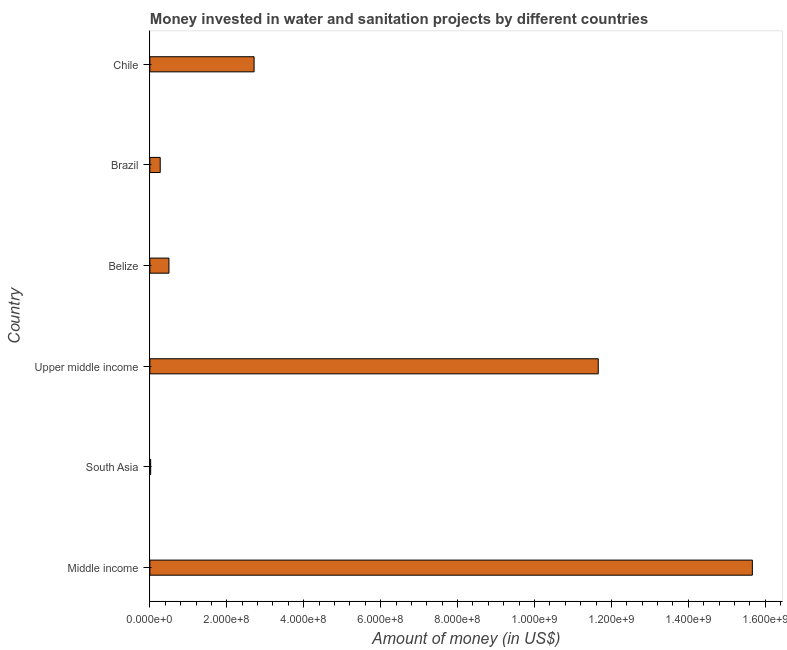Does the graph contain any zero values?
Keep it short and to the point. No. Does the graph contain grids?
Ensure brevity in your answer.  No. What is the title of the graph?
Your answer should be compact. Money invested in water and sanitation projects by different countries. What is the label or title of the X-axis?
Your answer should be compact. Amount of money (in US$). What is the label or title of the Y-axis?
Keep it short and to the point. Country. What is the investment in Brazil?
Provide a short and direct response. 2.69e+07. Across all countries, what is the maximum investment?
Offer a terse response. 1.57e+09. Across all countries, what is the minimum investment?
Give a very brief answer. 2.10e+06. In which country was the investment maximum?
Provide a succinct answer. Middle income. In which country was the investment minimum?
Provide a short and direct response. South Asia. What is the sum of the investment?
Offer a very short reply. 3.08e+09. What is the difference between the investment in Brazil and Middle income?
Give a very brief answer. -1.54e+09. What is the average investment per country?
Ensure brevity in your answer.  5.14e+08. What is the median investment?
Provide a short and direct response. 1.60e+08. What is the ratio of the investment in Belize to that in Middle income?
Make the answer very short. 0.03. Is the investment in Brazil less than that in Upper middle income?
Your response must be concise. Yes. Is the difference between the investment in Brazil and Middle income greater than the difference between any two countries?
Make the answer very short. No. What is the difference between the highest and the second highest investment?
Your answer should be compact. 4.01e+08. What is the difference between the highest and the lowest investment?
Keep it short and to the point. 1.56e+09. Are all the bars in the graph horizontal?
Your answer should be very brief. Yes. How many countries are there in the graph?
Offer a terse response. 6. Are the values on the major ticks of X-axis written in scientific E-notation?
Ensure brevity in your answer.  Yes. What is the Amount of money (in US$) of Middle income?
Give a very brief answer. 1.57e+09. What is the Amount of money (in US$) of South Asia?
Give a very brief answer. 2.10e+06. What is the Amount of money (in US$) in Upper middle income?
Offer a very short reply. 1.17e+09. What is the Amount of money (in US$) of Belize?
Your answer should be compact. 4.96e+07. What is the Amount of money (in US$) in Brazil?
Provide a short and direct response. 2.69e+07. What is the Amount of money (in US$) of Chile?
Offer a terse response. 2.71e+08. What is the difference between the Amount of money (in US$) in Middle income and South Asia?
Ensure brevity in your answer.  1.56e+09. What is the difference between the Amount of money (in US$) in Middle income and Upper middle income?
Offer a very short reply. 4.01e+08. What is the difference between the Amount of money (in US$) in Middle income and Belize?
Provide a short and direct response. 1.52e+09. What is the difference between the Amount of money (in US$) in Middle income and Brazil?
Make the answer very short. 1.54e+09. What is the difference between the Amount of money (in US$) in Middle income and Chile?
Give a very brief answer. 1.30e+09. What is the difference between the Amount of money (in US$) in South Asia and Upper middle income?
Your answer should be very brief. -1.16e+09. What is the difference between the Amount of money (in US$) in South Asia and Belize?
Your answer should be compact. -4.75e+07. What is the difference between the Amount of money (in US$) in South Asia and Brazil?
Provide a succinct answer. -2.48e+07. What is the difference between the Amount of money (in US$) in South Asia and Chile?
Ensure brevity in your answer.  -2.69e+08. What is the difference between the Amount of money (in US$) in Upper middle income and Belize?
Make the answer very short. 1.12e+09. What is the difference between the Amount of money (in US$) in Upper middle income and Brazil?
Ensure brevity in your answer.  1.14e+09. What is the difference between the Amount of money (in US$) in Upper middle income and Chile?
Your answer should be very brief. 8.95e+08. What is the difference between the Amount of money (in US$) in Belize and Brazil?
Ensure brevity in your answer.  2.27e+07. What is the difference between the Amount of money (in US$) in Belize and Chile?
Offer a very short reply. -2.21e+08. What is the difference between the Amount of money (in US$) in Brazil and Chile?
Your response must be concise. -2.44e+08. What is the ratio of the Amount of money (in US$) in Middle income to that in South Asia?
Your answer should be compact. 745.95. What is the ratio of the Amount of money (in US$) in Middle income to that in Upper middle income?
Offer a terse response. 1.34. What is the ratio of the Amount of money (in US$) in Middle income to that in Belize?
Make the answer very short. 31.58. What is the ratio of the Amount of money (in US$) in Middle income to that in Brazil?
Your answer should be very brief. 58.17. What is the ratio of the Amount of money (in US$) in Middle income to that in Chile?
Your answer should be very brief. 5.78. What is the ratio of the Amount of money (in US$) in South Asia to that in Upper middle income?
Offer a terse response. 0. What is the ratio of the Amount of money (in US$) in South Asia to that in Belize?
Keep it short and to the point. 0.04. What is the ratio of the Amount of money (in US$) in South Asia to that in Brazil?
Your answer should be compact. 0.08. What is the ratio of the Amount of money (in US$) in South Asia to that in Chile?
Offer a terse response. 0.01. What is the ratio of the Amount of money (in US$) in Upper middle income to that in Belize?
Keep it short and to the point. 23.5. What is the ratio of the Amount of money (in US$) in Upper middle income to that in Brazil?
Your response must be concise. 43.29. What is the ratio of the Amount of money (in US$) in Upper middle income to that in Chile?
Your response must be concise. 4.3. What is the ratio of the Amount of money (in US$) in Belize to that in Brazil?
Make the answer very short. 1.84. What is the ratio of the Amount of money (in US$) in Belize to that in Chile?
Make the answer very short. 0.18. What is the ratio of the Amount of money (in US$) in Brazil to that in Chile?
Provide a succinct answer. 0.1. 